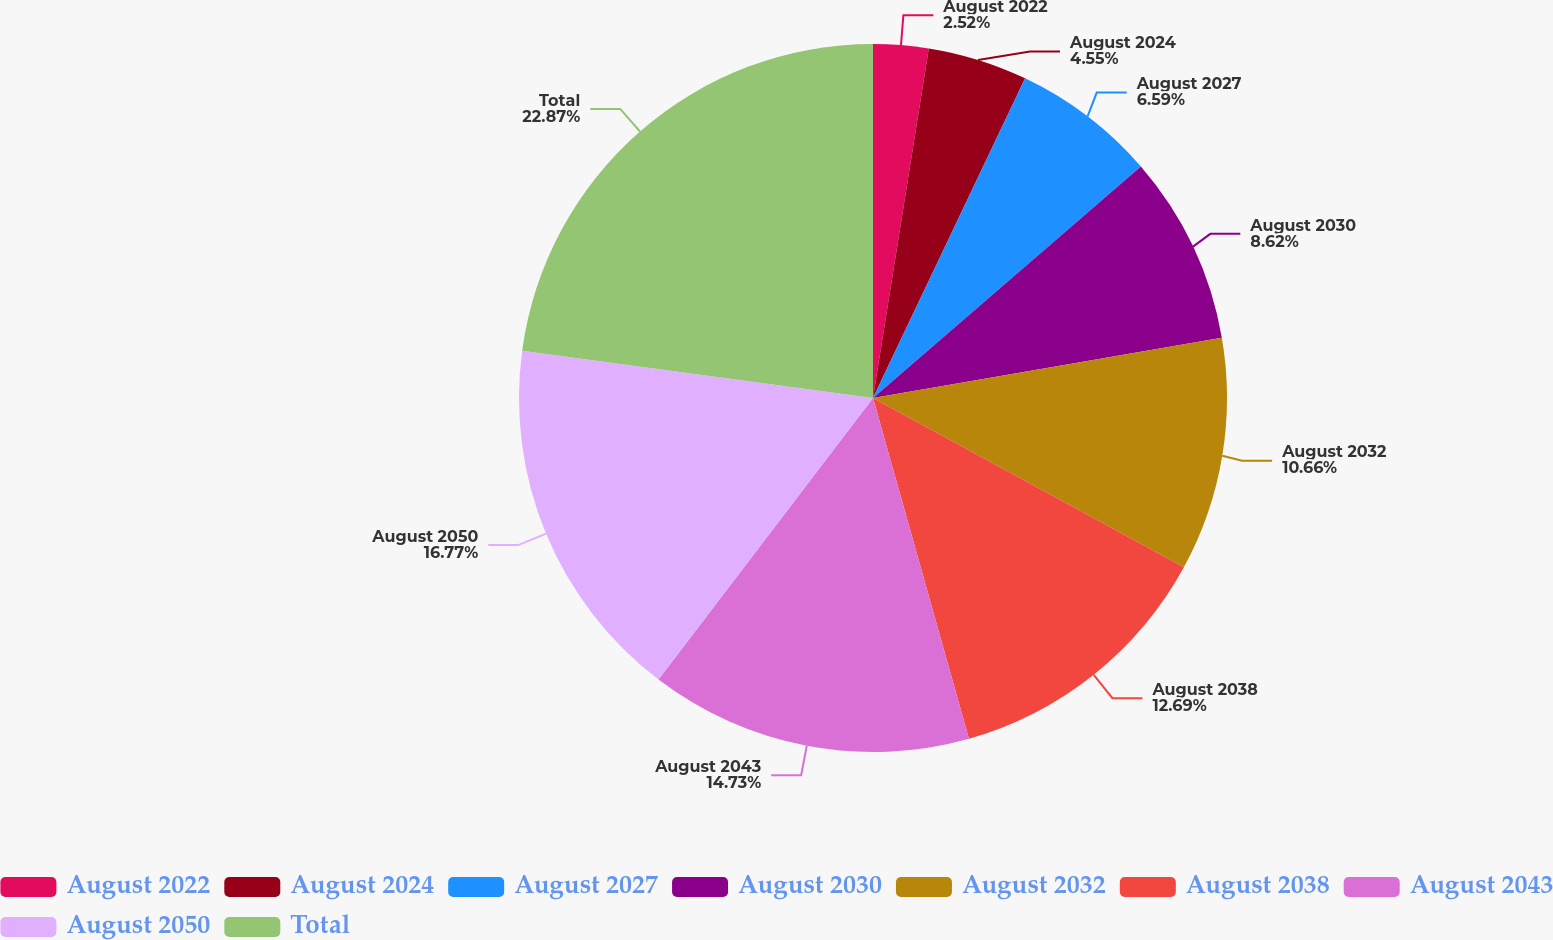Convert chart to OTSL. <chart><loc_0><loc_0><loc_500><loc_500><pie_chart><fcel>August 2022<fcel>August 2024<fcel>August 2027<fcel>August 2030<fcel>August 2032<fcel>August 2038<fcel>August 2043<fcel>August 2050<fcel>Total<nl><fcel>2.52%<fcel>4.55%<fcel>6.59%<fcel>8.62%<fcel>10.66%<fcel>12.69%<fcel>14.73%<fcel>16.77%<fcel>22.87%<nl></chart> 